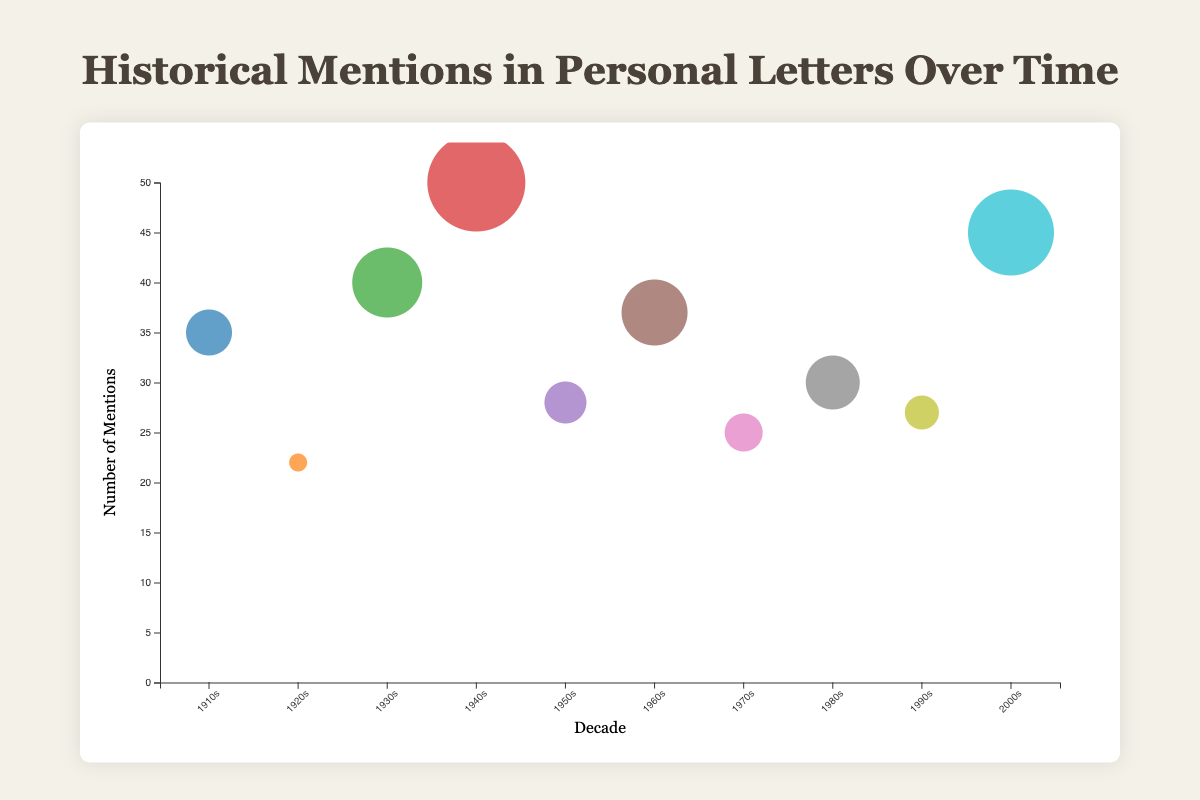How many mentions are recorded for the event "World War II"? The bubble chart shows the number of mentions on the y-axis. The bubble representing "World War II" is labeled with 50 mentions.
Answer: 50 Which decade has the highest number of mentions? By examining the y-axis values, the decade with the bubble at the highest point is the 1940s, indicating the highest number of mentions.
Answer: 1940s What is the impact factor associated with the "March on Washington"? The tooltip will display the impact factor when hovering over the bubble for the "March on Washington." It shows an impact factor of 3.7.
Answer: 3.7 Compare the number of mentions between the "Great Depression" and the "Roaring Twenties". Which one has more mentions? By looking at the y-axis values and comparing the heights of the corresponding bubbles, the "Great Depression" has 40 mentions, whereas the "Roaring Twenties" has 22 mentions. Thus, the "Great Depression" has more mentions.
Answer: Great Depression What is the average impact factor of the events "Prohibition in the United States" and "Dot-com Bubble"? The impact factors for "Prohibition in the United States" and "Dot-com Bubble" are 2.5 and 2.9, respectively. The average impact factor is calculated as (2.5 + 2.9) / 2 = 2.7.
Answer: 2.7 Identify the event with the smallest bubble size. What is its impact factor and mentions? The bubble size corresponds to the impact factor. The smallest bubble represents the "Prohibition in the United States" with an impact factor of 2.5. This event has 22 mentions.
Answer: Prohibition in the United States, 2.5 impact factor, 22 mentions How does the number of mentions for "9/11 Attacks" compare to "Vietnam War"? Compare the y-axis positions; "9/11 Attacks" has 45 mentions, while "Vietnam War" has 25 mentions. The "9/11 Attacks" has more mentions.
Answer: 9/11 Attacks Which event has the largest impact factor and what is its decade? The bubbles with the largest sizes indicate the highest impact factors. The "World War II" bubble, from the 1940s, has the largest impact factor of 4.5.
Answer: World War II, 1940s Among the decades 1980s and 1990s, which has more mentions? Compare the positions of the "End of Cold War" (1980s) and "Tech Boom" (1990s) bubbles on the y-axis. The "End of Cold War" has 30 mentions, while "Tech Boom" has 27 mentions.
Answer: 1980s 